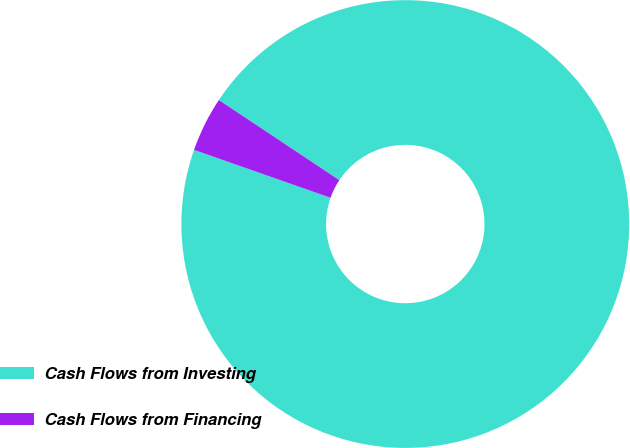Convert chart. <chart><loc_0><loc_0><loc_500><loc_500><pie_chart><fcel>Cash Flows from Investing<fcel>Cash Flows from Financing<nl><fcel>96.03%<fcel>3.97%<nl></chart> 